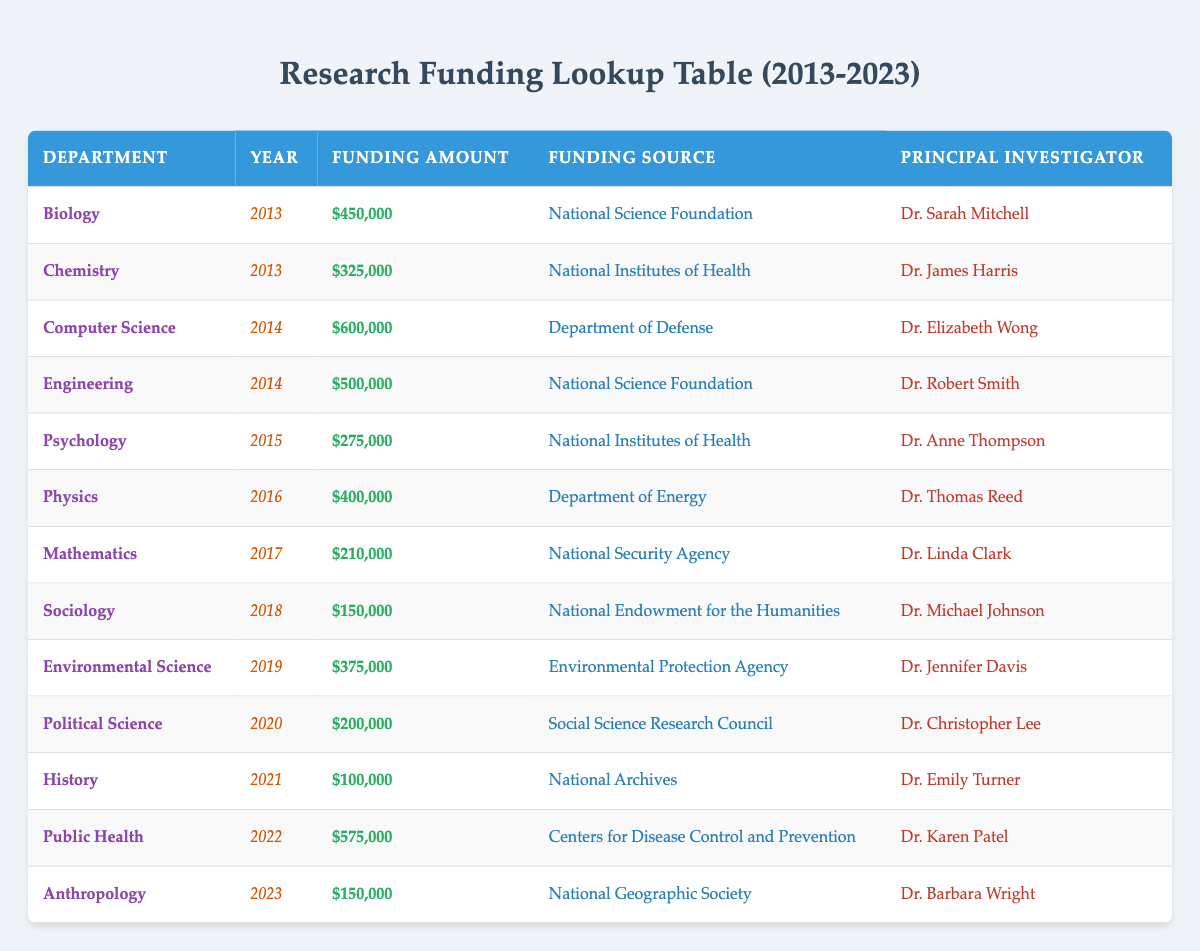What department received the highest funding amount in 2014? In 2014, the departments listed are Computer Science with $600,000 and Engineering with $500,000. The highest funding amount is $600,000 received by Computer Science.
Answer: Computer Science How much funding did the Psychology department receive in 2015? The table indicates that the Psychology department received $275,000 in 2015.
Answer: $275,000 Which principal investigator was associated with the funding from the National Endowment for the Humanities? The only principal investigator associated with the National Endowment for the Humanities is Dr. Michael Johnson from the Sociology department in 2018.
Answer: Dr. Michael Johnson Calculate the total funding amount received by Biology, Chemistry, and Physics departments over the years. Biology received $450,000 in 2013, Chemistry received $325,000 in 2013, and Physics received $400,000 in 2016. Summing these amounts gives $450,000 + $325,000 + $400,000 = $1,175,000.
Answer: $1,175,000 Did the Engineering department receive more funding than the Political Science department? Engineering received $500,000 in 2014, whereas Political Science received $200,000 in 2020. Since $500,000 is greater than $200,000, the statement is true.
Answer: Yes What was the total funding amount received by all departments in 2022 and 2023? In 2022, the funding amount was $575,000 for Public Health, and in 2023 it was $150,000 for Anthropology. Adding these amounts gives $575,000 + $150,000 = $725,000.
Answer: $725,000 Identify the year with the least amount of funding reported. The years listed are 2013 to 2023. The lowest funding reported is $100,000 in 2021 for the History department.
Answer: 2021 How many different funding sources are listed in the table? The table contains distinct funding sources: National Science Foundation, National Institutes of Health, Department of Defense, National Security Agency, Department of Energy, Environmental Protection Agency, Social Science Research Council, National Archives, Centers for Disease Control and Prevention, and National Geographic Society. Counting these gives a total of 10 different sources.
Answer: 10 What funding amount did the Environmental Science department receive compared to the Anthropology department? The Environmental Science department received $375,000 in 2019, whereas the Anthropology department received $150,000 in 2023. Comparing these amounts shows $375,000 is greater than $150,000.
Answer: $375,000 (Environmental Science) is greater than $150,000 (Anthropology) 